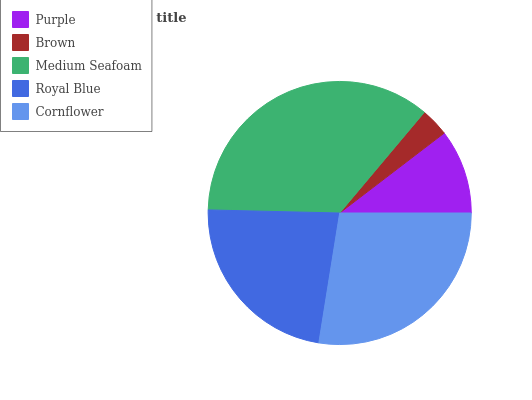Is Brown the minimum?
Answer yes or no. Yes. Is Medium Seafoam the maximum?
Answer yes or no. Yes. Is Medium Seafoam the minimum?
Answer yes or no. No. Is Brown the maximum?
Answer yes or no. No. Is Medium Seafoam greater than Brown?
Answer yes or no. Yes. Is Brown less than Medium Seafoam?
Answer yes or no. Yes. Is Brown greater than Medium Seafoam?
Answer yes or no. No. Is Medium Seafoam less than Brown?
Answer yes or no. No. Is Royal Blue the high median?
Answer yes or no. Yes. Is Royal Blue the low median?
Answer yes or no. Yes. Is Cornflower the high median?
Answer yes or no. No. Is Cornflower the low median?
Answer yes or no. No. 